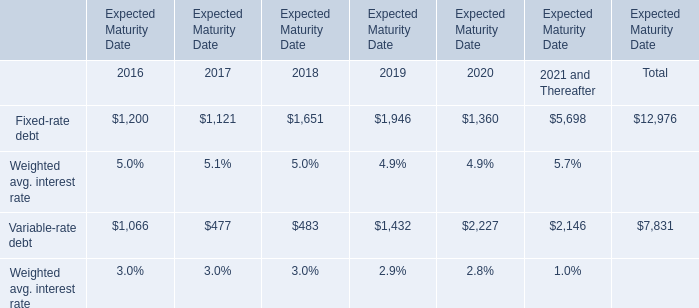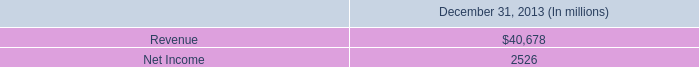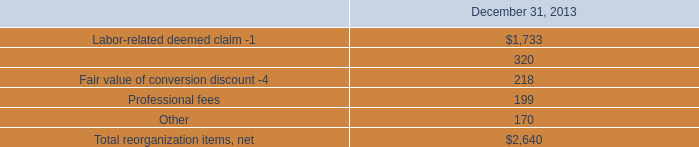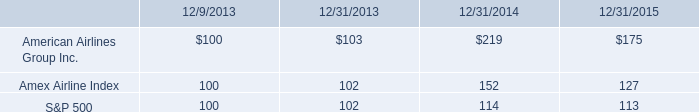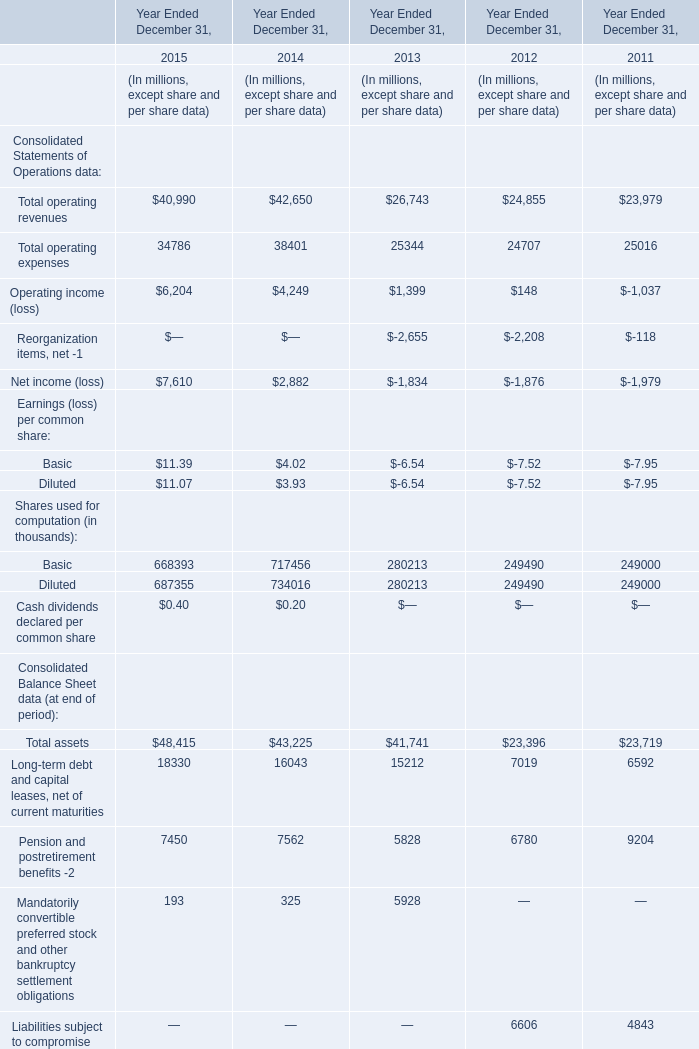what is the ratio of the professional fees to the other fees 
Computations: (1990 / 170)
Answer: 11.70588. 